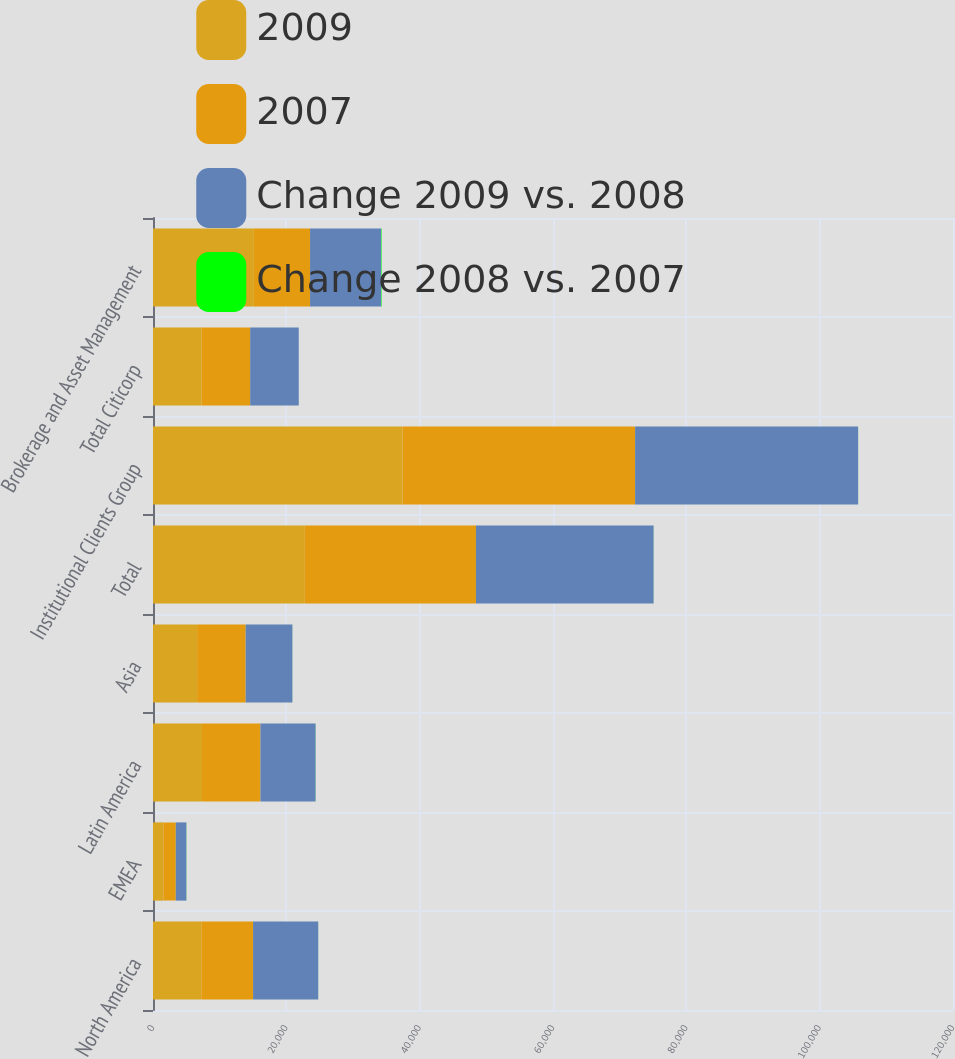<chart> <loc_0><loc_0><loc_500><loc_500><stacked_bar_chart><ecel><fcel>North America<fcel>EMEA<fcel>Latin America<fcel>Asia<fcel>Total<fcel>Institutional Clients Group<fcel>Total Citicorp<fcel>Brokerage and Asset Management<nl><fcel>2009<fcel>7246<fcel>1555<fcel>7354<fcel>6616<fcel>22771<fcel>37435<fcel>7287<fcel>15135<nl><fcel>2007<fcel>7764<fcel>1865<fcel>8758<fcel>7287<fcel>25674<fcel>34881<fcel>7287<fcel>8423<nl><fcel>Change 2009 vs. 2008<fcel>9773<fcel>1587<fcel>8279<fcel>7004<fcel>26643<fcel>33454<fcel>7287<fcel>10659<nl><fcel>Change 2008 vs. 2007<fcel>7<fcel>17<fcel>16<fcel>9<fcel>11<fcel>7<fcel>1<fcel>80<nl></chart> 